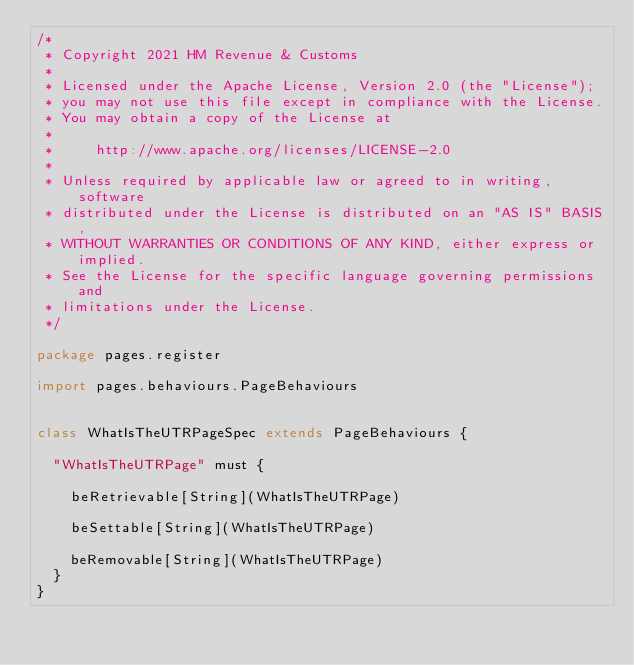<code> <loc_0><loc_0><loc_500><loc_500><_Scala_>/*
 * Copyright 2021 HM Revenue & Customs
 *
 * Licensed under the Apache License, Version 2.0 (the "License");
 * you may not use this file except in compliance with the License.
 * You may obtain a copy of the License at
 *
 *     http://www.apache.org/licenses/LICENSE-2.0
 *
 * Unless required by applicable law or agreed to in writing, software
 * distributed under the License is distributed on an "AS IS" BASIS,
 * WITHOUT WARRANTIES OR CONDITIONS OF ANY KIND, either express or implied.
 * See the License for the specific language governing permissions and
 * limitations under the License.
 */

package pages.register

import pages.behaviours.PageBehaviours


class WhatIsTheUTRPageSpec extends PageBehaviours {

  "WhatIsTheUTRPage" must {

    beRetrievable[String](WhatIsTheUTRPage)

    beSettable[String](WhatIsTheUTRPage)

    beRemovable[String](WhatIsTheUTRPage)
  }
}
</code> 